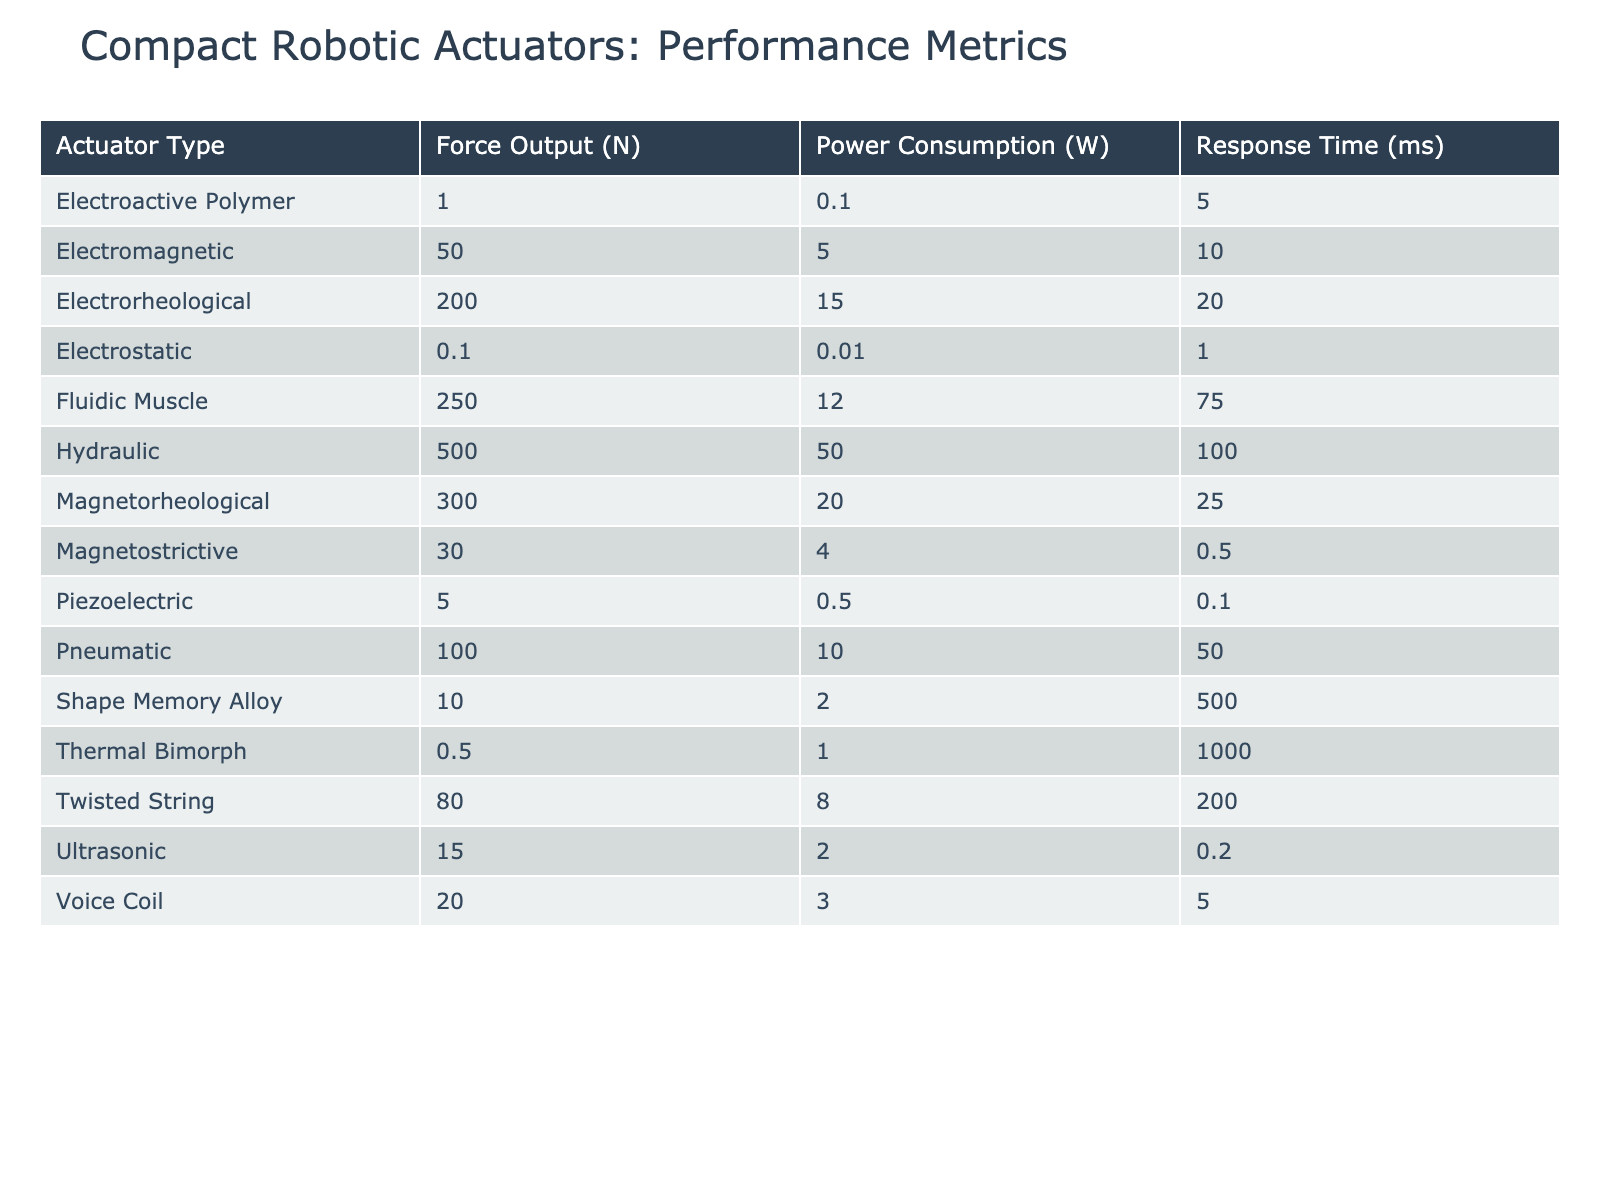What is the maximum force output among the actuators listed? The maximum force output can be identified by looking across the 'Force Output (N)' column for all actuator types. The values include 5, 10, 0.1, 50, 100, 500, 0.5, 1, 20, 30, 15, 200, 300, 80, and 250 N. The highest value is 500 N, associated with the Hydraulic actuator type.
Answer: 500 N Which actuator type has the lowest power consumption? The lowest power consumption value can be found by examining the 'Power Consumption (W)' column. The values are 0.5, 2, 0.01, 5, 10, 50, 1, 0.1, 3, 4, 2, 15, 20, 8, and 12 W. The smallest is 0.01 W for the Electrostatic actuator type.
Answer: 0.01 W What is the average response time of all actuation types listed? To calculate the average response time, we sum the values of 'Response Time (ms)' from all actuators: 0.1 + 500 + 1 + 10 + 50 + 100 + 1000 + 5 + 5 + 0.2 + 0.2 + 20 + 25 + 200 + 75 = 1997. There are 14 actuators, so the average is 1997 / 14 ≈ 142.64 ms.
Answer: 142.64 ms Are there any actuators that have a force output greater than 200 N? Reviewing the 'Force Output (N)' column, the values that exceed 200 N include 500, 250, and 300 N from the Hydraulic, Fluidic Muscle, and Magnetorheological actuator types, respectively. Thus, the answer is yes.
Answer: Yes Which material is used in the actuator type that consumes the most power? The actuator with the highest power consumption is the Hydraulic actuator, with a value of 50 W. The associated material for this actuator type is Stainless steel.
Answer: Stainless steel What is the total weight of all actuator types combined? To find the total weight, we add the weights from the 'Weight (g)' column: 2 + 1 + 0.5 + 15 + 8 + 50 + 1 + 0.2 + 25 + 10 + 12 + 40 + 60 + 3 + 30 = 242.7 g.
Answer: 242.7 g How many actuator types have a response time less than 5 ms? The 'Response Time (ms)' column has the values 0.1, 500, 1, 10, 50, 100, 1000, 5, 5, 0.2, 0.2, 20, 25, 200, and 75. Only the values 0.1 and 1 are less than 5 ms, which means there are 2 actuator types.
Answer: 2 What is the difference in cost between the most expensive and the least expensive actuator type? The costs (in $) are 45, 30, 60, 40, 25, 100, 20, 35, 55, 80, 70, 120, 150, 50, and 90. The most expensive is 150 (Magnetorheological) and the least expensive is 20 (Thermal Bimorph). The difference is 150 - 20 = 130.
Answer: 130 What is the average force output of the actuators made from silicone rubber? The only actuator made from silicone rubber is the Pneumatic type, which has a force output of 100 N. Since there is only one data point, the average is simply 100 N.
Answer: 100 N 